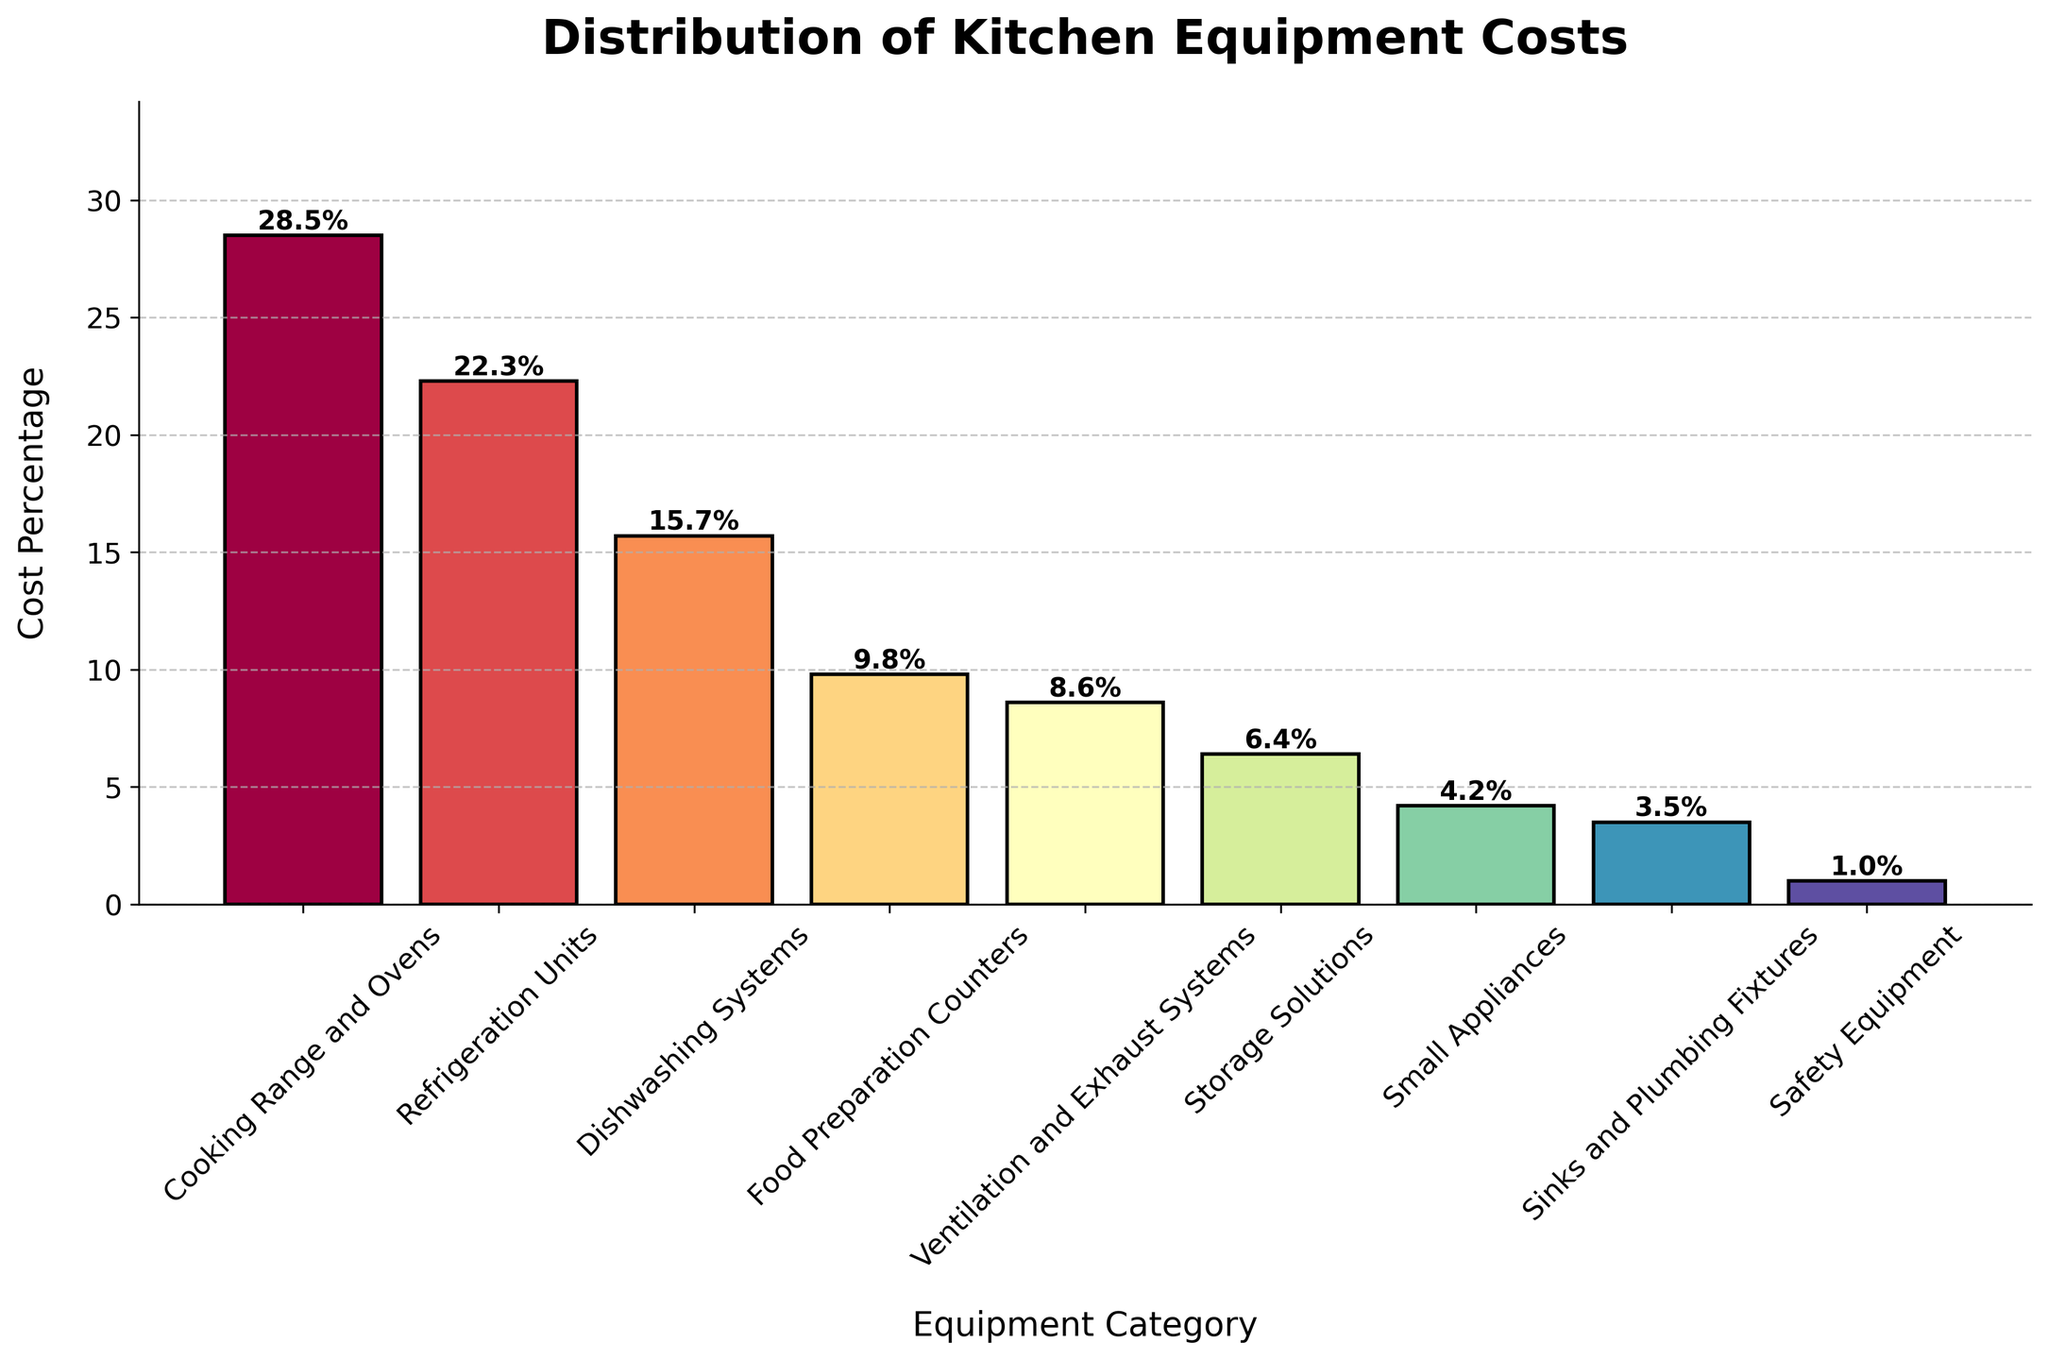Which category has the highest cost percentage? The bar with the greatest height represents the highest cost percentage. The "Cooking Range and Ovens" category has the highest bar with 28.5%.
Answer: Cooking Range and Ovens Which category has the lowest cost percentage? The bar with the smallest height represents the lowest cost percentage. The "Safety Equipment" category has the lowest bar with 1.0%.
Answer: Safety Equipment What is the combined cost percentage for Refrigeration Units and Dishwashing Systems? Add the cost percentages for Refrigeration Units and Dishwashing Systems: 22.3% + 15.7% = 38%.
Answer: 38% How much higher is the cost percentage of Cooking Range and Ovens compared to Ventilation and Exhaust Systems? Subtract the cost percentage of Ventilation and Exhaust Systems from that of Cooking Range and Ovens: 28.5% - 8.6% = 19.9%.
Answer: 19.9% Which equipment categories have cost percentages less than Storage Solutions? Look for bars with heights lower than the Storage Solutions category (6.4%). Small Appliances (4.2%), Sinks and Plumbing Fixtures (3.5%), and Safety Equipment (1.0%) all have lower percentages.
Answer: Small Appliances, Sinks and Plumbing Fixtures, Safety Equipment Are there more categories with cost percentages above or below 10%? Count the categories above 10% (Cooking Range and Ovens, Refrigeration Units, Dishwashing Systems) and below 10% (Food Preparation Counters, Ventilation and Exhaust Systems, Storage Solutions, Small Appliances, Sinks and Plumbing Fixtures, Safety Equipment). There are 3 categories above 10% and 6 categories below 10%.
Answer: Below What is the total cost percentage for categories related to heating (Cooking Range and Ovens) and cooling (Refrigeration Units)? Add the cost percentages of Cooking Range and Ovens and Refrigeration Units: 28.5% + 22.3% = 50.8%.
Answer: 50.8% Which categories are almost equal in their cost percentages? Compare the heights of the bars to see which ones are close in value. Ventilation and Exhaust Systems (8.6%) and Storage Solutions (6.4%) are not exactly equal but are fairly close.
Answer: Ventilation and Exhaust Systems, Storage Solutions How does the cost percentage of Food Preparation Counters compare to that of Small Appliances? Look at the height difference between the two categories. Food Preparation Counters have a higher percentage (9.8%) compared to Small Appliances (4.2%).
Answer: Food Preparation Counters > Small Appliances 